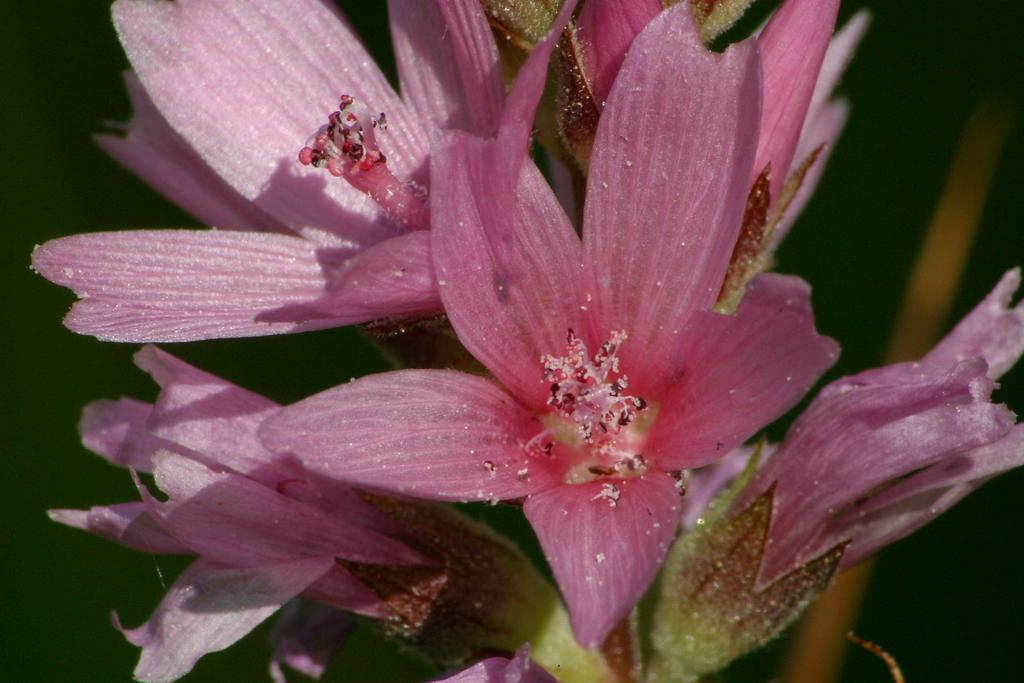What type of flowers are in the foreground of the image? There are pink flowers in the foreground of the image. What can be observed in the center of the flowers? The flowers have pollen grains in the middle. What is visible in the background of the image? There is a plant in the background of the image. What type of kettle is being used to water the flowers in the image? There is no kettle present in the image; it only features flowers and a plant. 